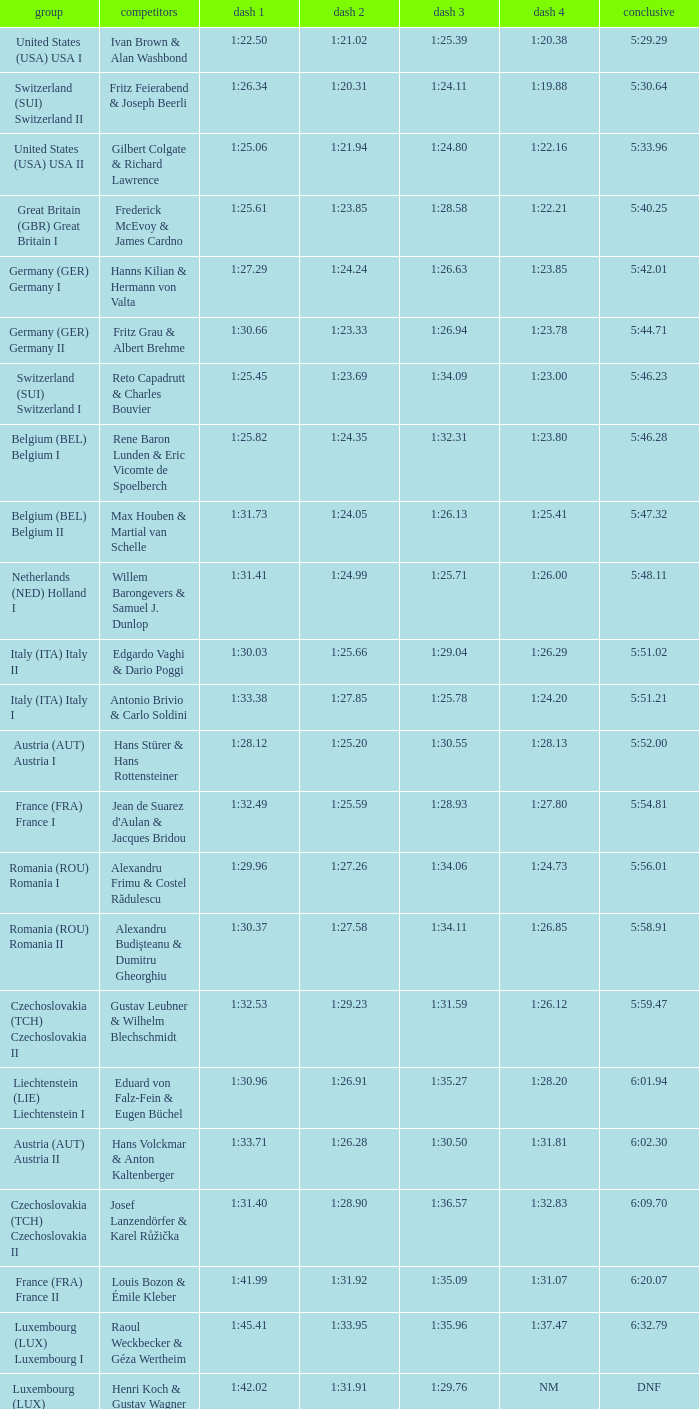Which Final has a Team of liechtenstein (lie) liechtenstein i? 6:01.94. 